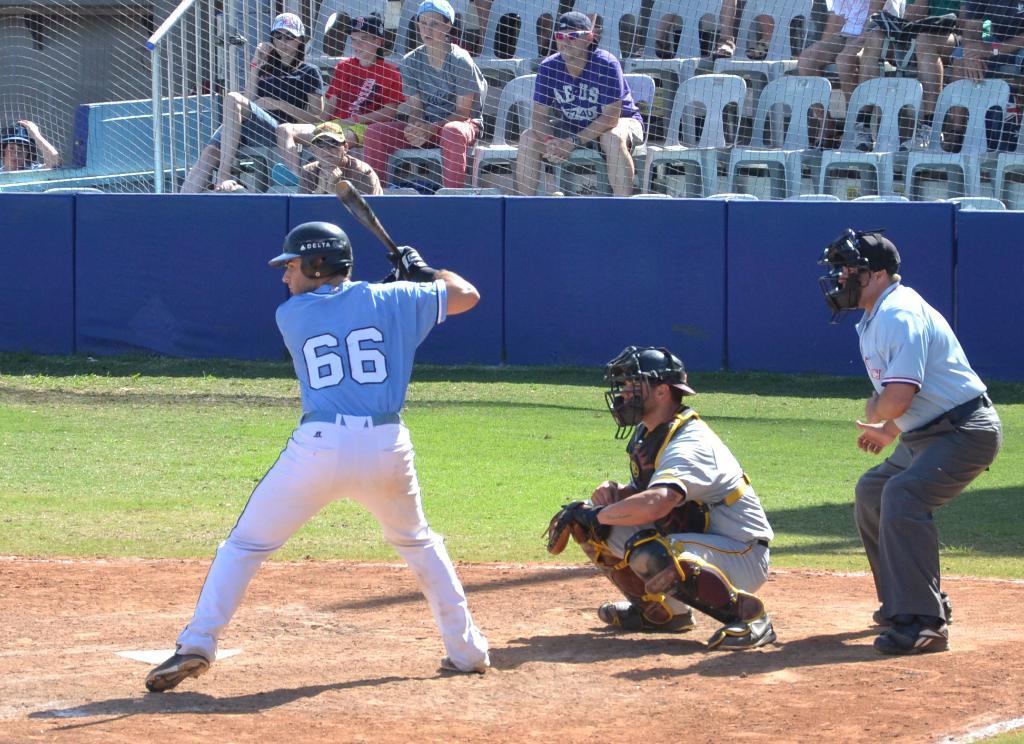What is the batter's number?
Ensure brevity in your answer.  66. 